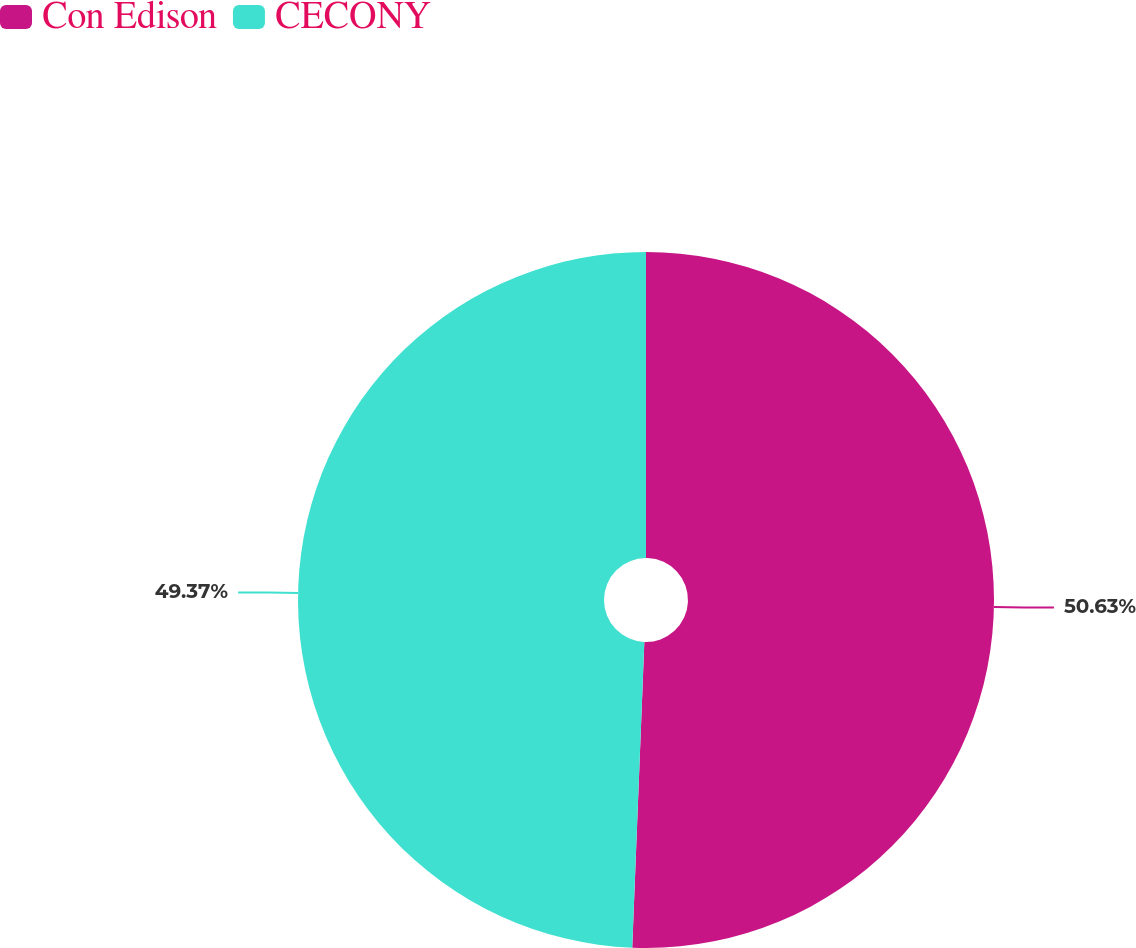Convert chart to OTSL. <chart><loc_0><loc_0><loc_500><loc_500><pie_chart><fcel>Con Edison<fcel>CECONY<nl><fcel>50.63%<fcel>49.37%<nl></chart> 